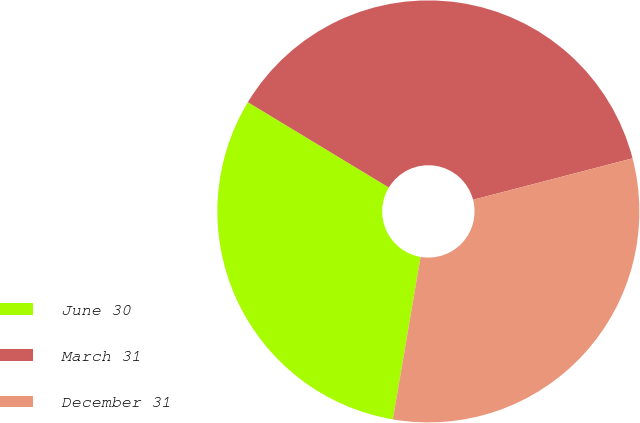<chart> <loc_0><loc_0><loc_500><loc_500><pie_chart><fcel>June 30<fcel>March 31<fcel>December 31<nl><fcel>30.97%<fcel>37.29%<fcel>31.74%<nl></chart> 